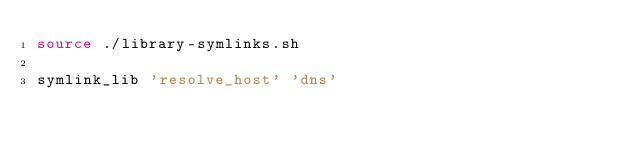<code> <loc_0><loc_0><loc_500><loc_500><_Bash_>source ./library-symlinks.sh

symlink_lib 'resolve_host' 'dns'
</code> 